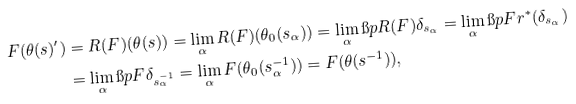<formula> <loc_0><loc_0><loc_500><loc_500>F ( \theta ( s ) ^ { \prime } ) & = R ( F ) ( \theta ( s ) ) = \lim _ { \alpha } R ( F ) ( \theta _ { 0 } ( s _ { \alpha } ) ) = \lim _ { \alpha } \i p { R ( F ) } { \delta _ { s _ { \alpha } } } = \lim _ { \alpha } \i p { F } { r ^ { * } ( \delta _ { s _ { \alpha } } ) } \\ & = \lim _ { \alpha } \i p { F } { \delta _ { s _ { \alpha } ^ { - 1 } } } = \lim _ { \alpha } F ( \theta _ { 0 } ( s _ { \alpha } ^ { - 1 } ) ) = F ( \theta ( s ^ { - 1 } ) ) ,</formula> 